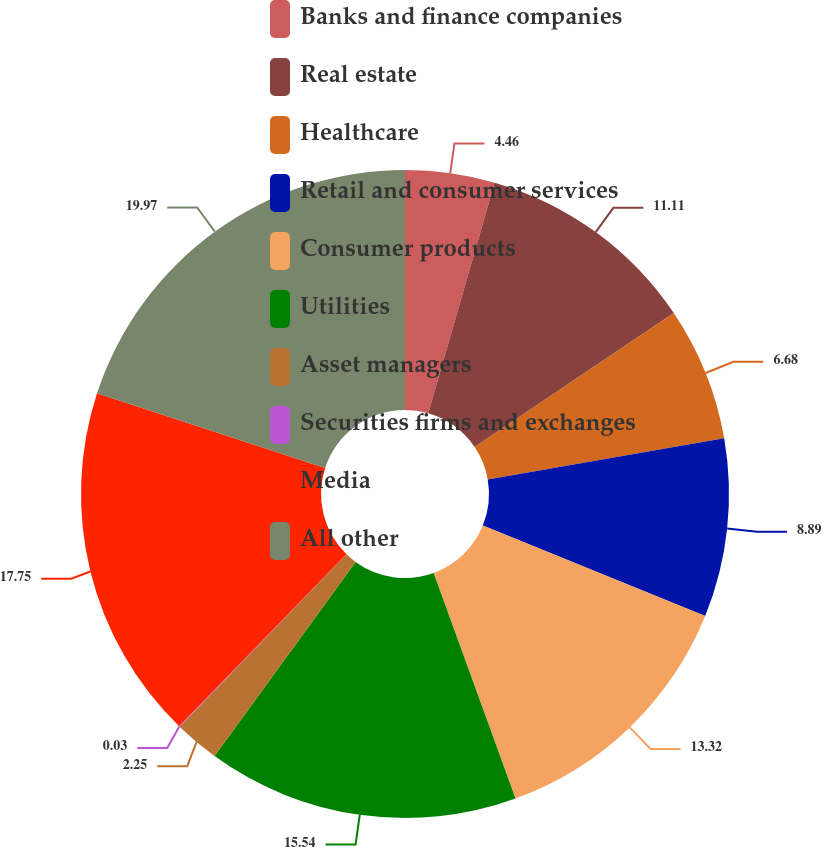<chart> <loc_0><loc_0><loc_500><loc_500><pie_chart><fcel>Banks and finance companies<fcel>Real estate<fcel>Healthcare<fcel>Retail and consumer services<fcel>Consumer products<fcel>Utilities<fcel>Asset managers<fcel>Securities firms and exchanges<fcel>Media<fcel>All other<nl><fcel>4.46%<fcel>11.11%<fcel>6.68%<fcel>8.89%<fcel>13.32%<fcel>15.54%<fcel>2.25%<fcel>0.03%<fcel>17.75%<fcel>19.97%<nl></chart> 